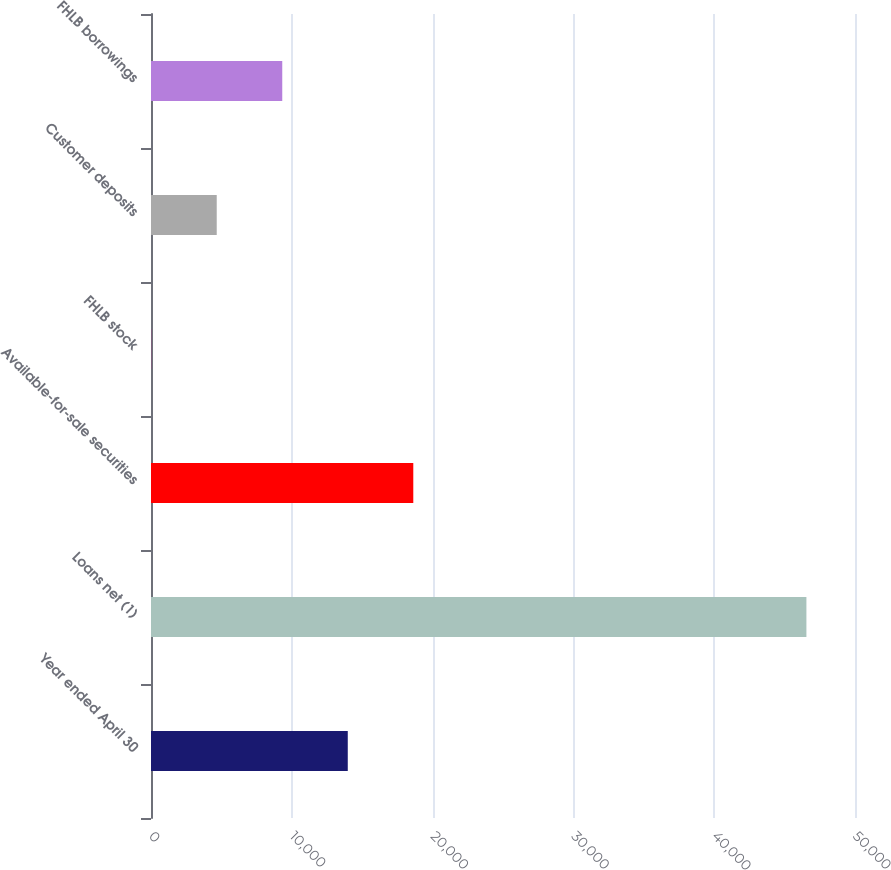Convert chart. <chart><loc_0><loc_0><loc_500><loc_500><bar_chart><fcel>Year ended April 30<fcel>Loans net (1)<fcel>Available-for-sale securities<fcel>FHLB stock<fcel>Customer deposits<fcel>FHLB borrowings<nl><fcel>13975.2<fcel>46549<fcel>18628.6<fcel>15<fcel>4668.4<fcel>9321.8<nl></chart> 